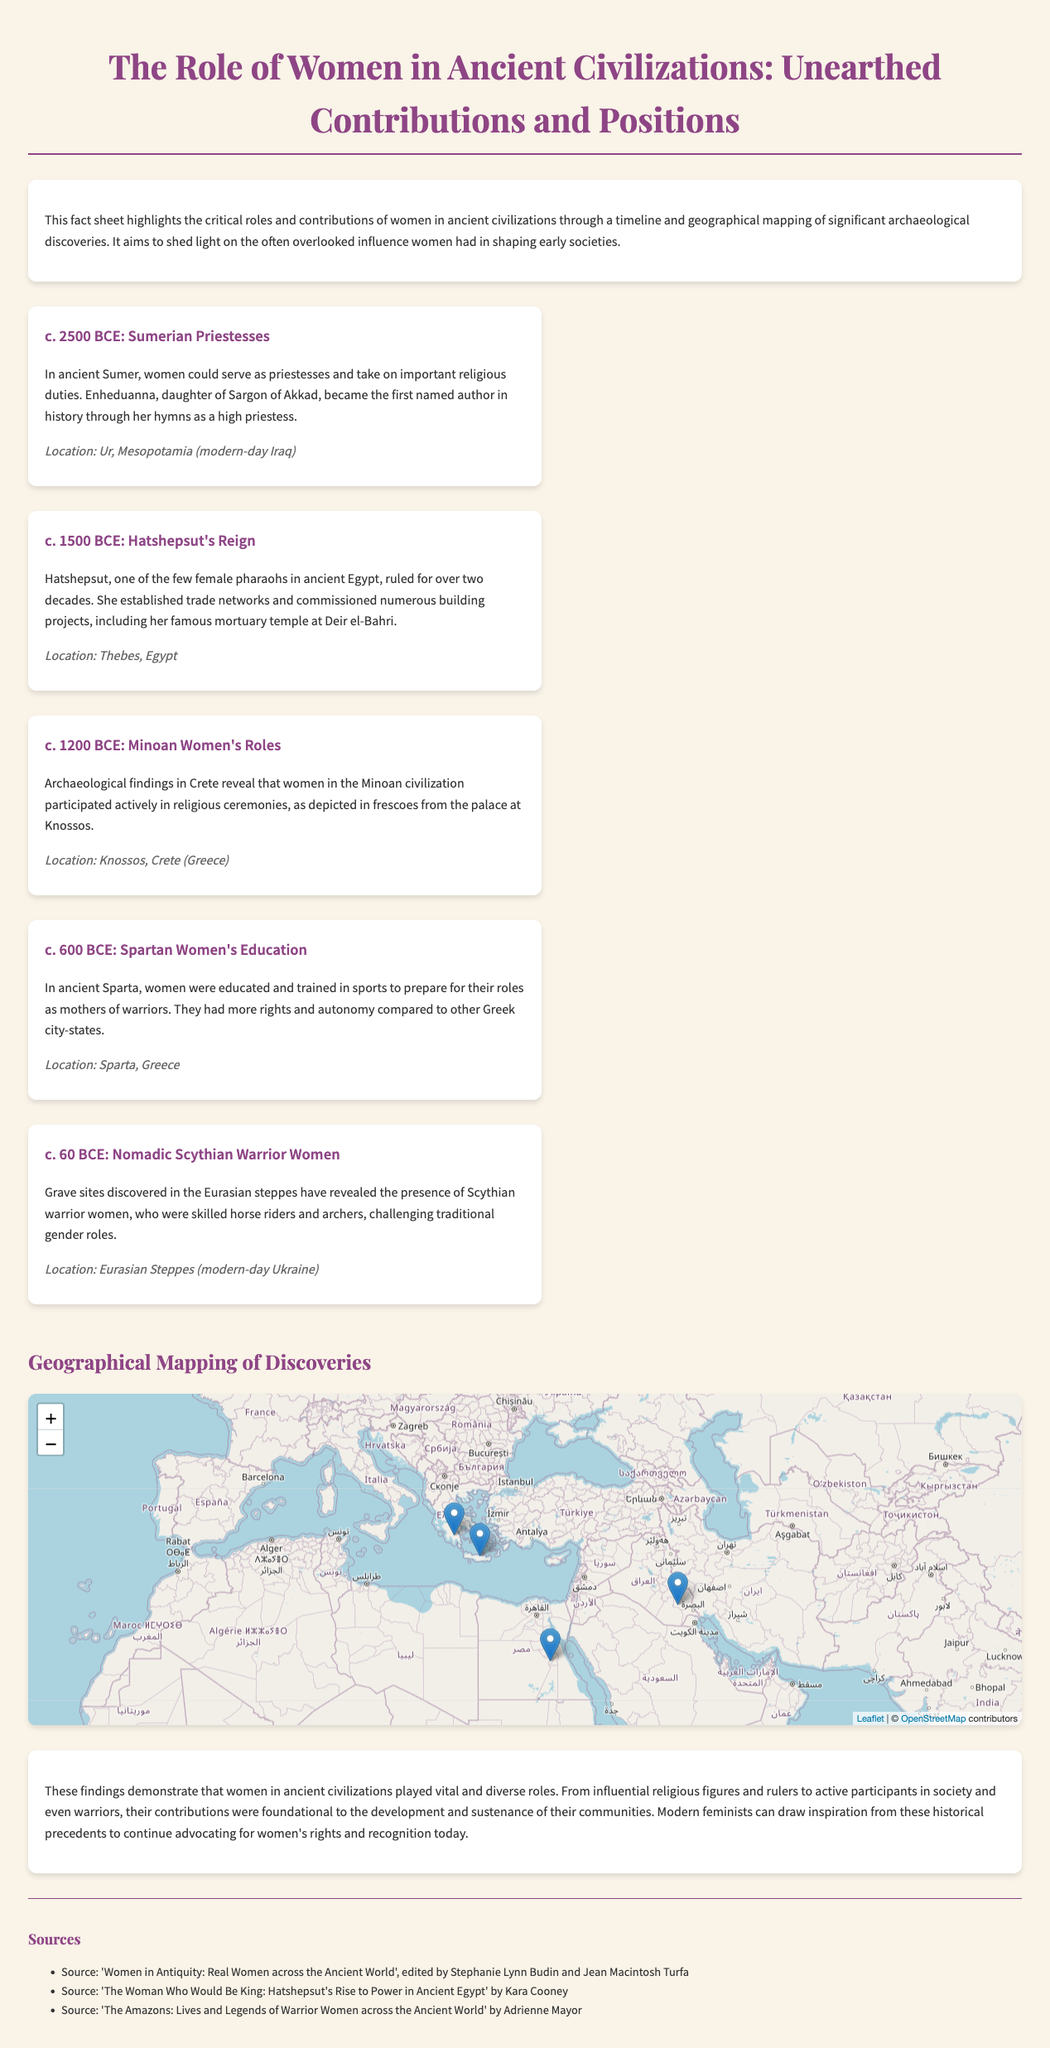What civilization did Enheduanna belong to? Enheduanna was a Sumerian priestess, indicating her civilization was Sumer.
Answer: Sumer What role did Hatshepsut hold in ancient Egypt? Hatshepsut was one of the few female pharaohs, signifying her leadership position.
Answer: Pharaoh What is the approximate date for Minoan women's roles? The document states the date as c. 1200 BCE, which is when Minoan women participated in religious ceremonies.
Answer: c. 1200 BCE Which location is associated with Spartan women's education? The document indicates that Spartan women's education took place in Sparta, Greece.
Answer: Sparta What did archaeological findings in the Eurasian steppes reveal? The findings included the presence of Scythian warrior women, which challenges traditional gender roles.
Answer: Warrior women Which ancient civilization is noted for women serving as priestesses? The document mentions the Sumerian civilization regarding the role of women as priestesses.
Answer: Sumerian What was one of Hatshepsut's notable achievements? Hatshepsut is noted for establishing trade networks and commissioning her mortuary temple.
Answer: Mortuary temple What is the main purpose of the fact sheet? The fact sheet aims to highlight the critical roles and contributions of women in ancient civilizations.
Answer: Advocate for women's contributions What visual aid is included in the document? The document includes a geographical map showcasing significant archaeological discoveries related to women's roles.
Answer: Map 